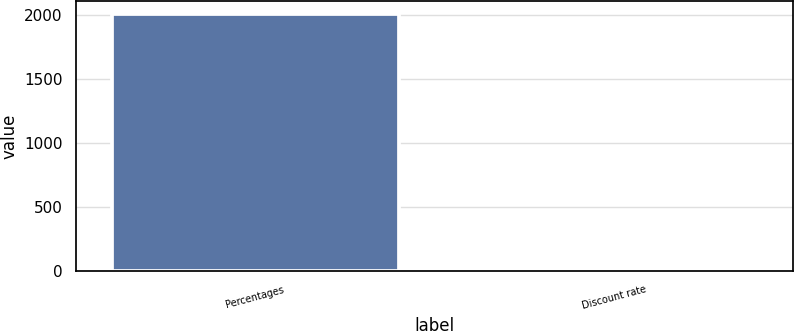<chart> <loc_0><loc_0><loc_500><loc_500><bar_chart><fcel>Percentages<fcel>Discount rate<nl><fcel>2005<fcel>5.75<nl></chart> 